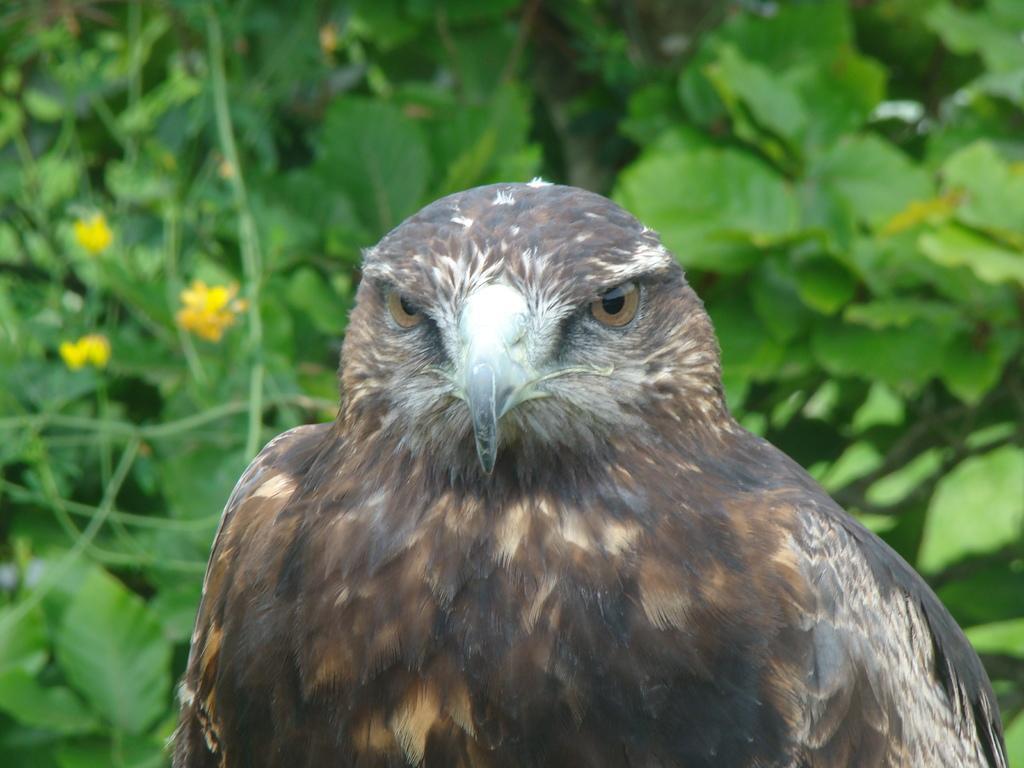Could you give a brief overview of what you see in this image? In the center of the image there is a eagle. At the background of the image there are leaves. 